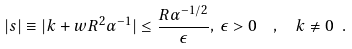Convert formula to latex. <formula><loc_0><loc_0><loc_500><loc_500>| s | \equiv | k + w R ^ { 2 } \alpha ^ { - 1 } | \leq \frac { R \alpha ^ { - 1 / 2 } } { \epsilon } , \, \epsilon > 0 \ \ , \ \ k \neq 0 \ .</formula> 